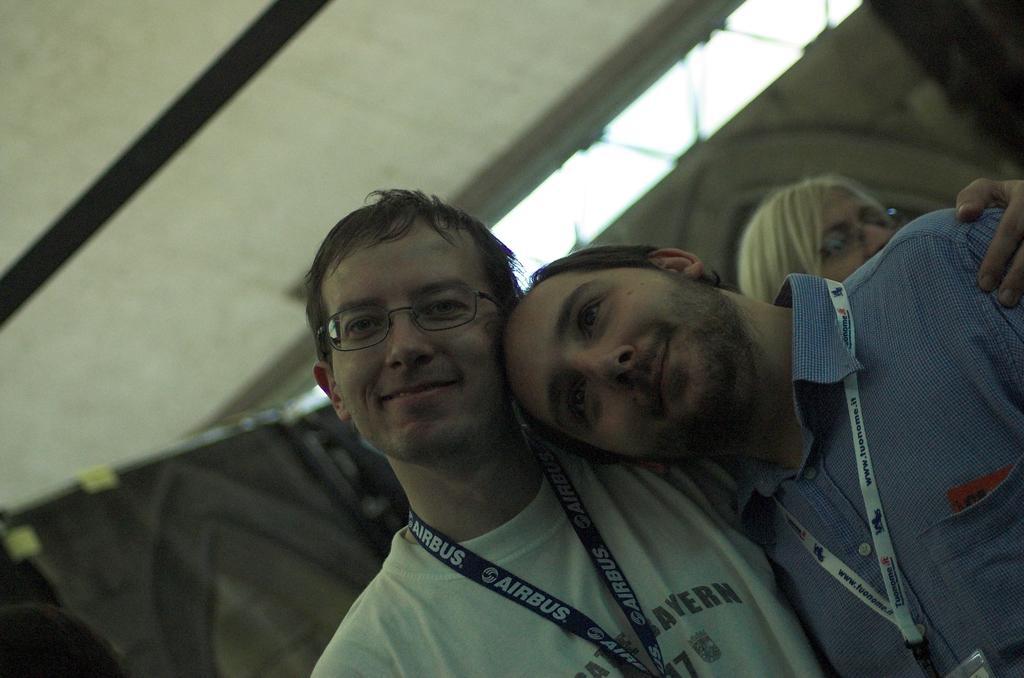Can you describe this image briefly? In the picture I can see people among them two men in front of the image are smiling and wearing ID cards. The background of the image is blurred. 